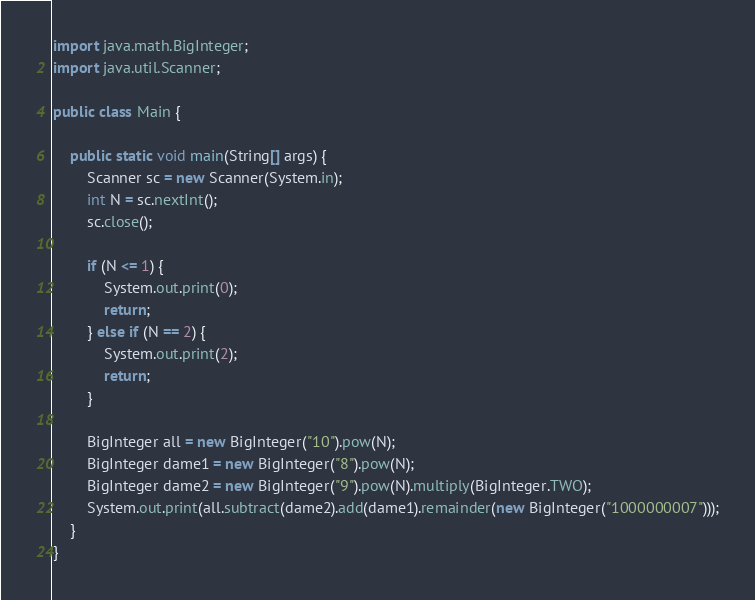<code> <loc_0><loc_0><loc_500><loc_500><_Java_>import java.math.BigInteger;
import java.util.Scanner;

public class Main {

	public static void main(String[] args) {
		Scanner sc = new Scanner(System.in);
		int N = sc.nextInt();
		sc.close();

		if (N <= 1) {
			System.out.print(0);
			return;
		} else if (N == 2) {
			System.out.print(2);
			return;
		}

		BigInteger all = new BigInteger("10").pow(N);
		BigInteger dame1 = new BigInteger("8").pow(N);
		BigInteger dame2 = new BigInteger("9").pow(N).multiply(BigInteger.TWO);
		System.out.print(all.subtract(dame2).add(dame1).remainder(new BigInteger("1000000007")));
	}
}</code> 